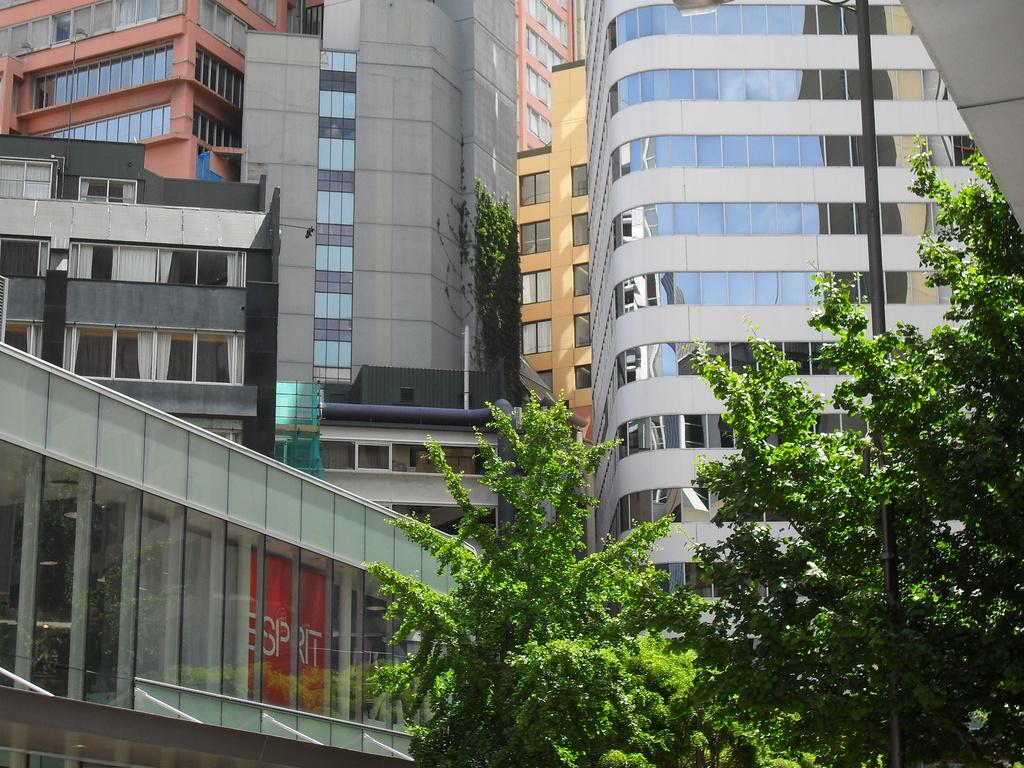Where was the image taken? The image was taken outdoors. What can be seen in the background of the image? There are many buildings in the image. What type of vegetation is present in the image? There are trees with leaves, stems, and branches in the image. What is attached to the pole in the image? There is a street light attached to the pole in the image. What type of dinner is being served in the image? There is no dinner present in the image; it is an outdoor scene with buildings, trees, and a street light. What is the relation between the trees and the street light in the image? There is no direct relation between the trees and the street light in the image; they are separate elements in the scene. 